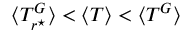<formula> <loc_0><loc_0><loc_500><loc_500>\langle T _ { r ^ { ^ { * } } } ^ { G } \rangle < \langle T \rangle < \langle T ^ { G } \rangle</formula> 